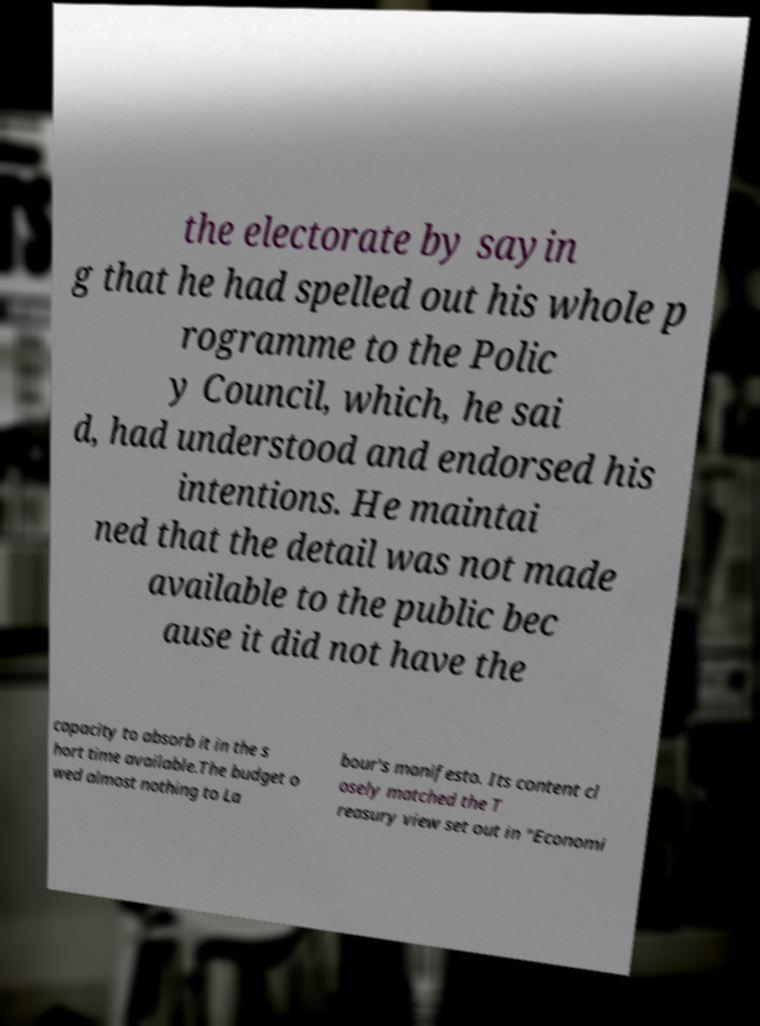For documentation purposes, I need the text within this image transcribed. Could you provide that? the electorate by sayin g that he had spelled out his whole p rogramme to the Polic y Council, which, he sai d, had understood and endorsed his intentions. He maintai ned that the detail was not made available to the public bec ause it did not have the capacity to absorb it in the s hort time available.The budget o wed almost nothing to La bour's manifesto. Its content cl osely matched the T reasury view set out in "Economi 